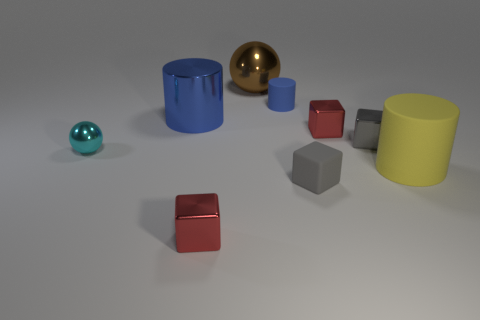Subtract all matte cubes. How many cubes are left? 3 Subtract all red spheres. How many blue cylinders are left? 2 Subtract 2 cylinders. How many cylinders are left? 1 Subtract all cyan balls. How many balls are left? 1 Subtract all cylinders. How many objects are left? 6 Subtract all purple blocks. Subtract all cyan spheres. How many blocks are left? 4 Add 7 small red things. How many small red things exist? 9 Subtract 0 purple balls. How many objects are left? 9 Subtract all purple matte objects. Subtract all matte cylinders. How many objects are left? 7 Add 3 large blue cylinders. How many large blue cylinders are left? 4 